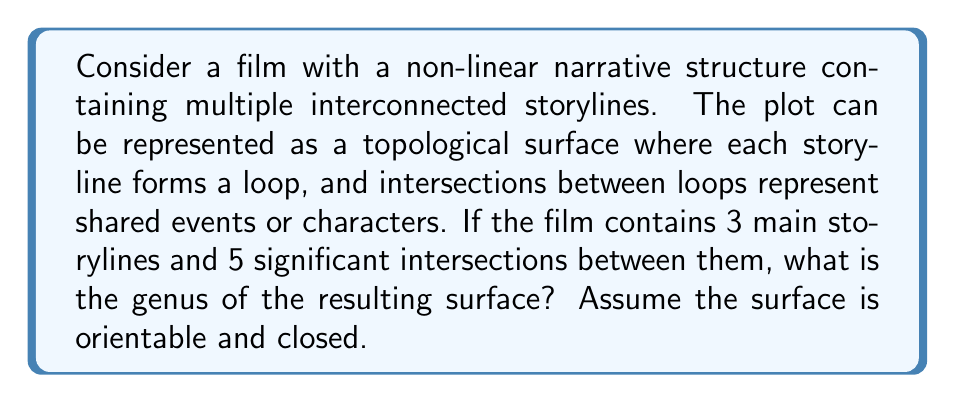Help me with this question. To solve this problem, we'll use concepts from algebraic topology, specifically the Euler characteristic and its relation to the genus of a surface.

1) First, let's identify the components of our surface:
   - Vertices (V): These are the intersection points between storylines. We have 5 intersections.
   - Edges (E): These are the segments of storylines between intersections. 
   - Faces (F): These are the regions bounded by the edges.

2) To calculate the number of edges:
   - Each intersection point (vertex) must be connected to 4 edges (2 from each storyline).
   - Total number of edge-ends = 5 vertices × 4 = 20
   - Since each edge has 2 ends, E = 20 ÷ 2 = 10

3) To calculate the number of faces:
   - We have 3 main storylines, which will create 4 faces (3 internal + 1 external)

4) Now we can calculate the Euler characteristic (χ):
   $$ χ = V - E + F $$
   $$ χ = 5 - 10 + 4 = -1 $$

5) For a closed orientable surface, the Euler characteristic is related to the genus (g) by the formula:
   $$ χ = 2 - 2g $$

6) Substituting our calculated χ:
   $$ -1 = 2 - 2g $$

7) Solving for g:
   $$ -3 = -2g $$
   $$ g = \frac{3}{2} $$

Therefore, the genus of the surface is 3/2.
Answer: The genus of the surface representing the film's plot structure is $\frac{3}{2}$. 